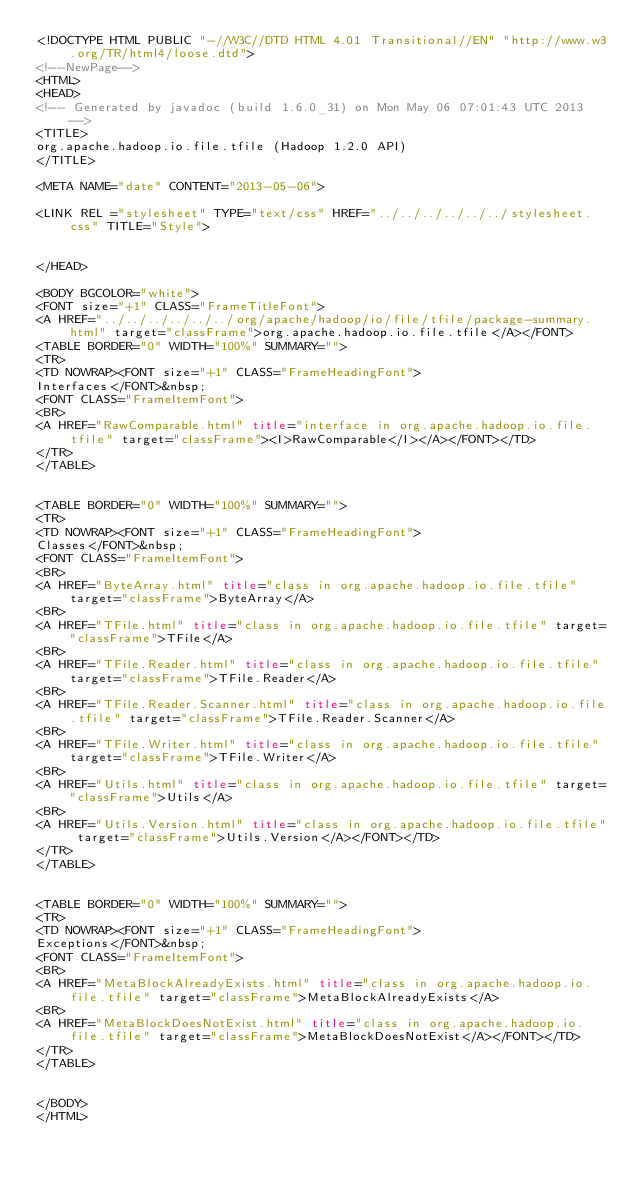Convert code to text. <code><loc_0><loc_0><loc_500><loc_500><_HTML_><!DOCTYPE HTML PUBLIC "-//W3C//DTD HTML 4.01 Transitional//EN" "http://www.w3.org/TR/html4/loose.dtd">
<!--NewPage-->
<HTML>
<HEAD>
<!-- Generated by javadoc (build 1.6.0_31) on Mon May 06 07:01:43 UTC 2013 -->
<TITLE>
org.apache.hadoop.io.file.tfile (Hadoop 1.2.0 API)
</TITLE>

<META NAME="date" CONTENT="2013-05-06">

<LINK REL ="stylesheet" TYPE="text/css" HREF="../../../../../../stylesheet.css" TITLE="Style">


</HEAD>

<BODY BGCOLOR="white">
<FONT size="+1" CLASS="FrameTitleFont">
<A HREF="../../../../../../org/apache/hadoop/io/file/tfile/package-summary.html" target="classFrame">org.apache.hadoop.io.file.tfile</A></FONT>
<TABLE BORDER="0" WIDTH="100%" SUMMARY="">
<TR>
<TD NOWRAP><FONT size="+1" CLASS="FrameHeadingFont">
Interfaces</FONT>&nbsp;
<FONT CLASS="FrameItemFont">
<BR>
<A HREF="RawComparable.html" title="interface in org.apache.hadoop.io.file.tfile" target="classFrame"><I>RawComparable</I></A></FONT></TD>
</TR>
</TABLE>


<TABLE BORDER="0" WIDTH="100%" SUMMARY="">
<TR>
<TD NOWRAP><FONT size="+1" CLASS="FrameHeadingFont">
Classes</FONT>&nbsp;
<FONT CLASS="FrameItemFont">
<BR>
<A HREF="ByteArray.html" title="class in org.apache.hadoop.io.file.tfile" target="classFrame">ByteArray</A>
<BR>
<A HREF="TFile.html" title="class in org.apache.hadoop.io.file.tfile" target="classFrame">TFile</A>
<BR>
<A HREF="TFile.Reader.html" title="class in org.apache.hadoop.io.file.tfile" target="classFrame">TFile.Reader</A>
<BR>
<A HREF="TFile.Reader.Scanner.html" title="class in org.apache.hadoop.io.file.tfile" target="classFrame">TFile.Reader.Scanner</A>
<BR>
<A HREF="TFile.Writer.html" title="class in org.apache.hadoop.io.file.tfile" target="classFrame">TFile.Writer</A>
<BR>
<A HREF="Utils.html" title="class in org.apache.hadoop.io.file.tfile" target="classFrame">Utils</A>
<BR>
<A HREF="Utils.Version.html" title="class in org.apache.hadoop.io.file.tfile" target="classFrame">Utils.Version</A></FONT></TD>
</TR>
</TABLE>


<TABLE BORDER="0" WIDTH="100%" SUMMARY="">
<TR>
<TD NOWRAP><FONT size="+1" CLASS="FrameHeadingFont">
Exceptions</FONT>&nbsp;
<FONT CLASS="FrameItemFont">
<BR>
<A HREF="MetaBlockAlreadyExists.html" title="class in org.apache.hadoop.io.file.tfile" target="classFrame">MetaBlockAlreadyExists</A>
<BR>
<A HREF="MetaBlockDoesNotExist.html" title="class in org.apache.hadoop.io.file.tfile" target="classFrame">MetaBlockDoesNotExist</A></FONT></TD>
</TR>
</TABLE>


</BODY>
</HTML>
</code> 